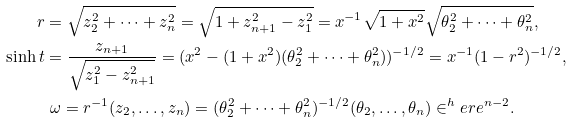<formula> <loc_0><loc_0><loc_500><loc_500>r & = \sqrt { z _ { 2 } ^ { 2 } + \dots + z _ { n } ^ { 2 } } = \sqrt { 1 + z _ { n + 1 } ^ { 2 } - z _ { 1 } ^ { 2 } } = x ^ { - 1 } \sqrt { 1 + x ^ { 2 } } \sqrt { \theta _ { 2 } ^ { 2 } + \dots + \theta _ { n } ^ { 2 } } , \\ \sinh t & = \frac { z _ { n + 1 } } { \sqrt { z _ { 1 } ^ { 2 } - z _ { n + 1 } ^ { 2 } } } = ( x ^ { 2 } - ( 1 + x ^ { 2 } ) ( \theta _ { 2 } ^ { 2 } + \dots + \theta _ { n } ^ { 2 } ) ) ^ { - 1 / 2 } = x ^ { - 1 } ( 1 - r ^ { 2 } ) ^ { - 1 / 2 } , \\ & \ \omega = r ^ { - 1 } ( z _ { 2 } , \dots , z _ { n } ) = ( \theta _ { 2 } ^ { 2 } + \dots + \theta _ { n } ^ { 2 } ) ^ { - 1 / 2 } ( \theta _ { 2 } , \dots , \theta _ { n } ) \in ^ { h } e r e ^ { n - 2 } .</formula> 